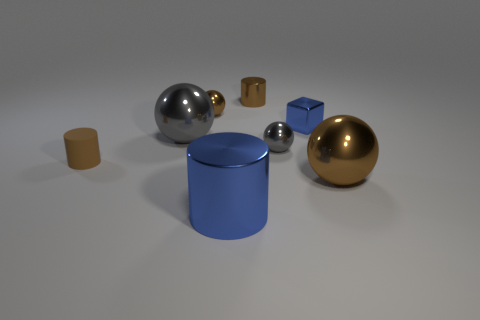Subtract all blue spheres. Subtract all gray blocks. How many spheres are left? 4 Add 1 big red cubes. How many objects exist? 9 Subtract all blocks. How many objects are left? 7 Subtract 0 green blocks. How many objects are left? 8 Subtract all small green rubber balls. Subtract all tiny spheres. How many objects are left? 6 Add 7 tiny gray metallic balls. How many tiny gray metallic balls are left? 8 Add 8 green things. How many green things exist? 8 